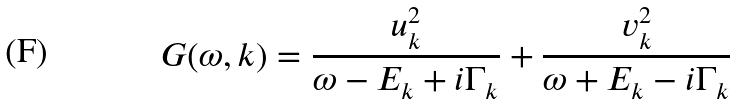<formula> <loc_0><loc_0><loc_500><loc_500>G ( \omega , { k } ) = \frac { u ^ { 2 } _ { k } } { \omega - E _ { k } + i \Gamma _ { k } } + \frac { v ^ { 2 } _ { k } } { \omega + E _ { k } - i \Gamma _ { k } }</formula> 